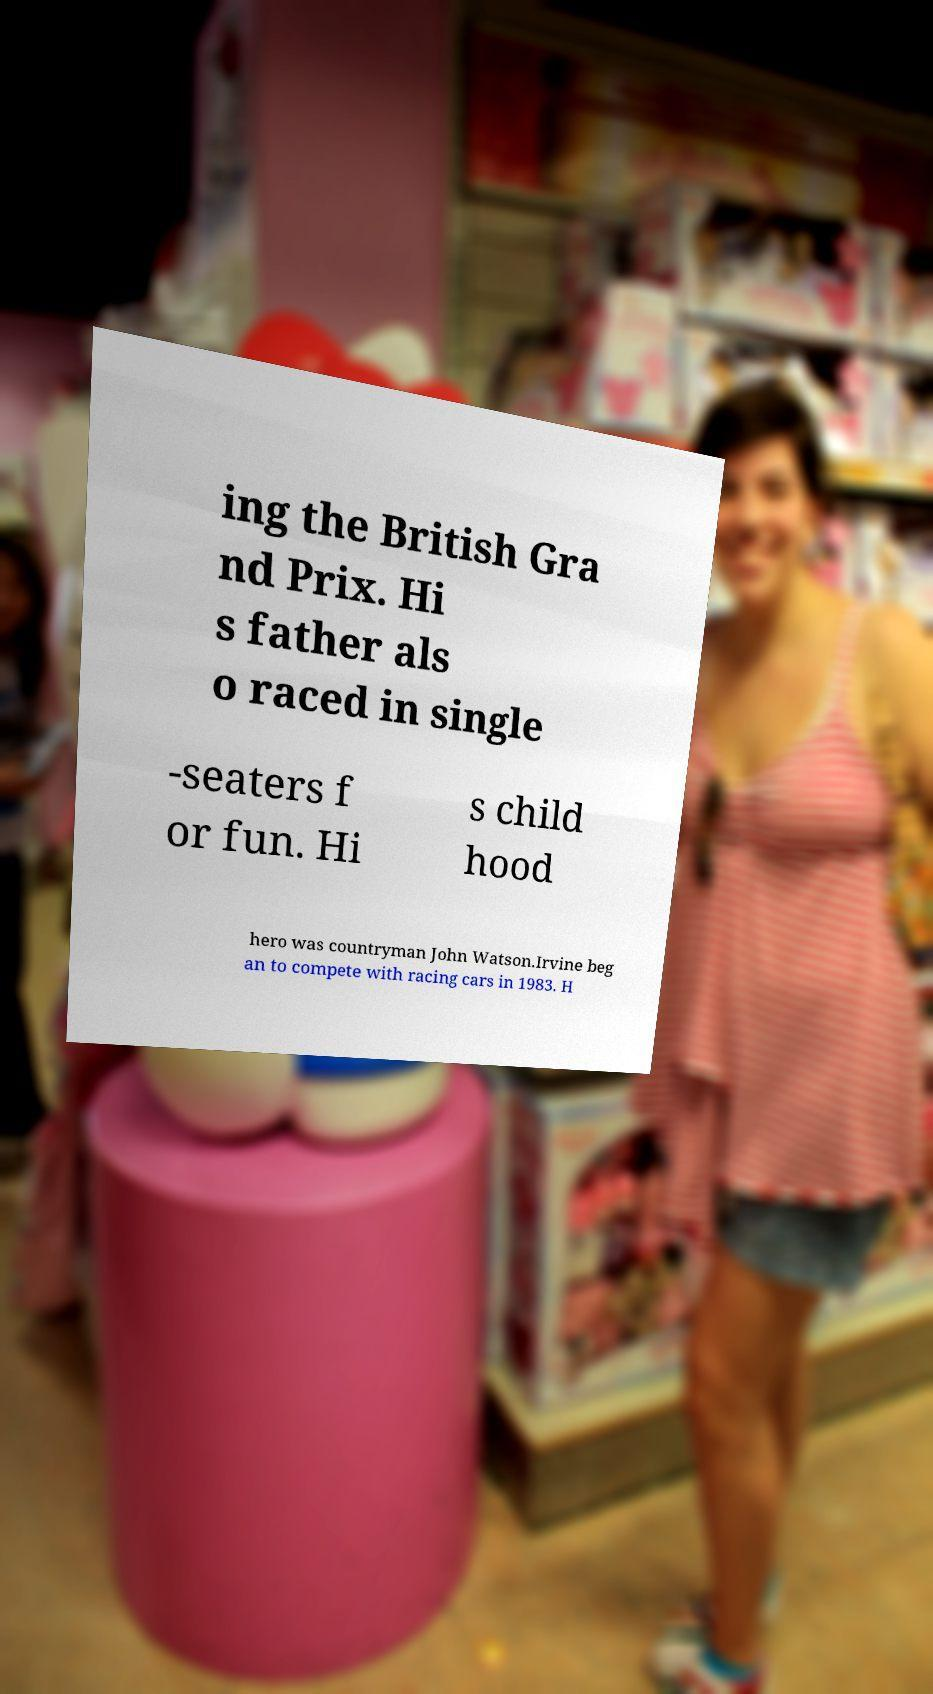Can you accurately transcribe the text from the provided image for me? ing the British Gra nd Prix. Hi s father als o raced in single -seaters f or fun. Hi s child hood hero was countryman John Watson.Irvine beg an to compete with racing cars in 1983. H 